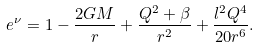<formula> <loc_0><loc_0><loc_500><loc_500>e ^ { \nu } = 1 - \frac { 2 G M } { r } + \frac { Q ^ { 2 } + \beta } { r ^ { 2 } } + \frac { l ^ { 2 } Q ^ { 4 } } { 2 0 r ^ { 6 } } .</formula> 